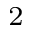<formula> <loc_0><loc_0><loc_500><loc_500>_ { 2 }</formula> 